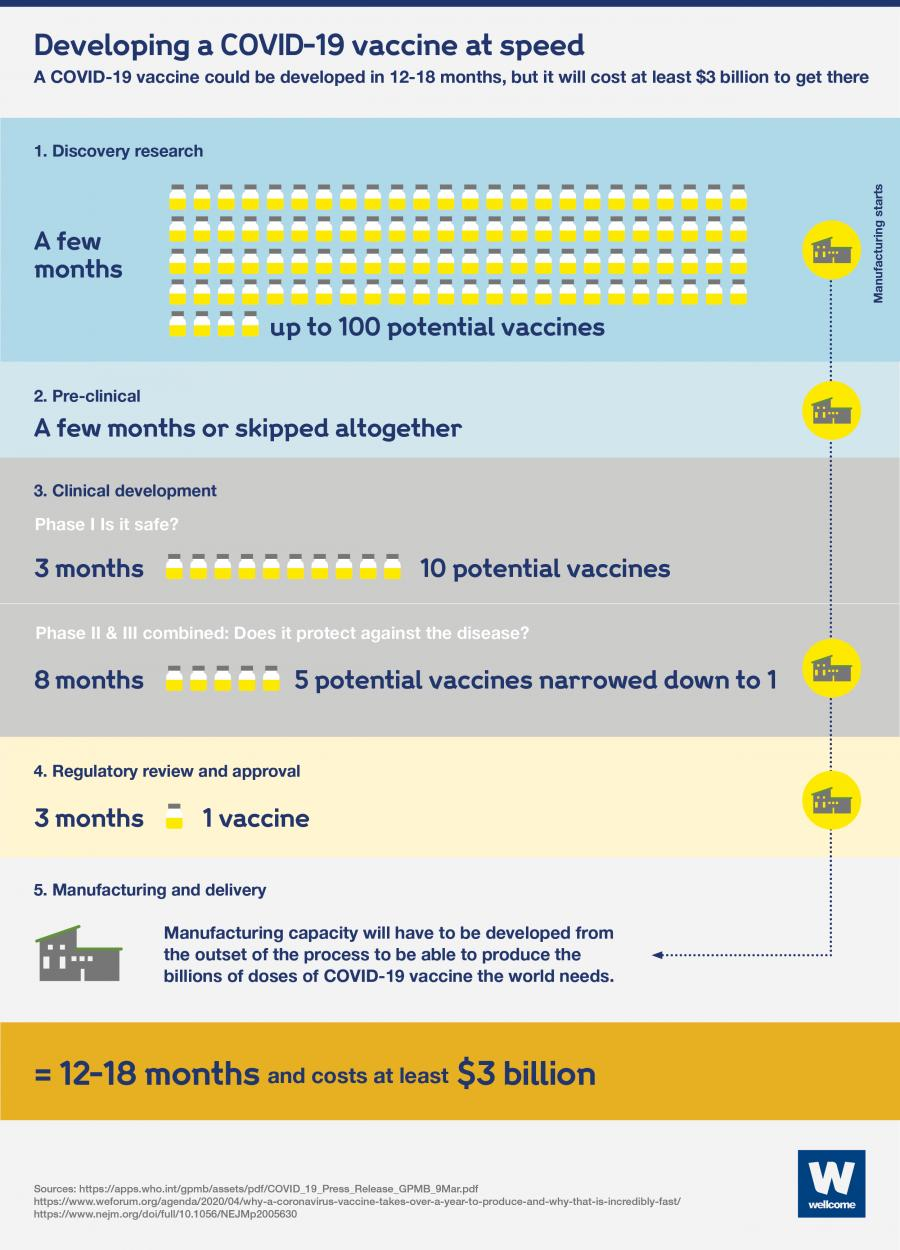Give some essential details in this illustration. During Phase I, it is expected that ten vaccines will be developed. The process of developing a vaccine involves numerous steps that must be completed in order for it to become available. Specifically, the steps leading to the availability of a vaccine may vary, but typically involve stages such as research and development, clinical trials, regulatory review, and distribution and administration. 